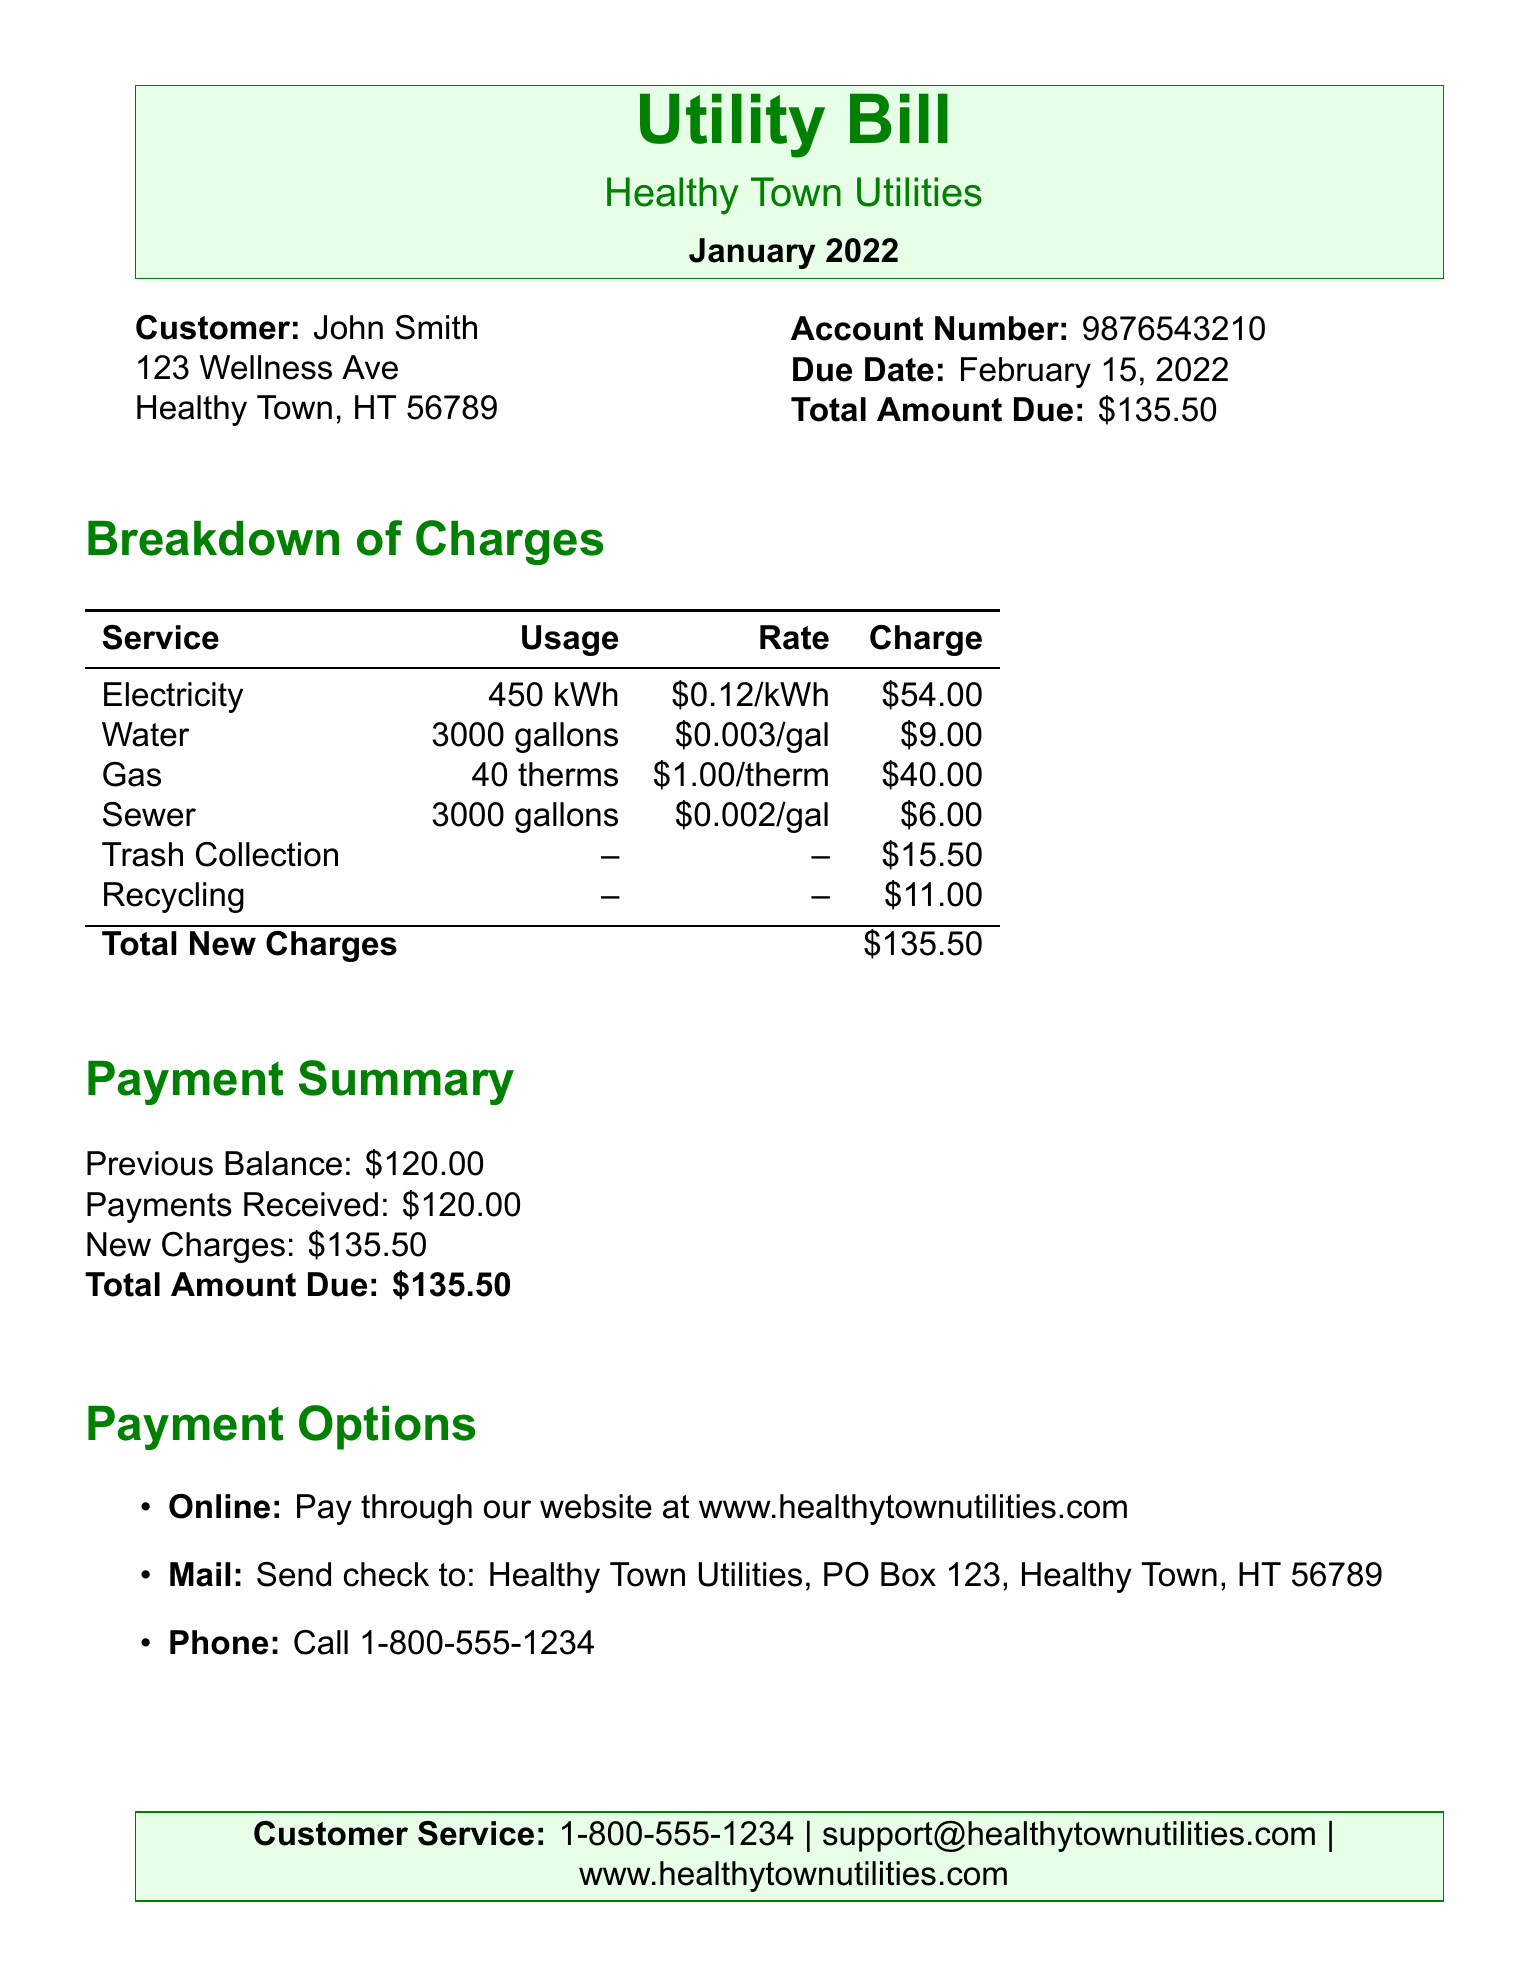What is the customer name? The customer name is listed at the top of the document under the customer information.
Answer: John Smith What is the total amount due? The total amount due is stated clearly in the account information section of the document.
Answer: $135.50 What is the due date? The due date for payment is mentioned alongside the total amount due.
Answer: February 15, 2022 How much is the charge for Electricity? The charge for Electricity is found in the breakdown of charges table.
Answer: $54.00 What is the usage of Water? The usage of Water is specified in the breakdown of charges.
Answer: 3000 gallons How much did the previous balance amount to? The previous balance is indicated in the payment summary section of the document.
Answer: $120.00 What payment option is provided for online payments? The payment options are listed, including one for online payments with a URL.
Answer: www.healthytownutilities.com What is the charge for Trash Collection? The charge for Trash Collection is listed in the breakdown of charges table.
Answer: $15.50 How many therms of Gas were used? The amount of Gas usage can be found in the breakdown of charges section.
Answer: 40 therms 